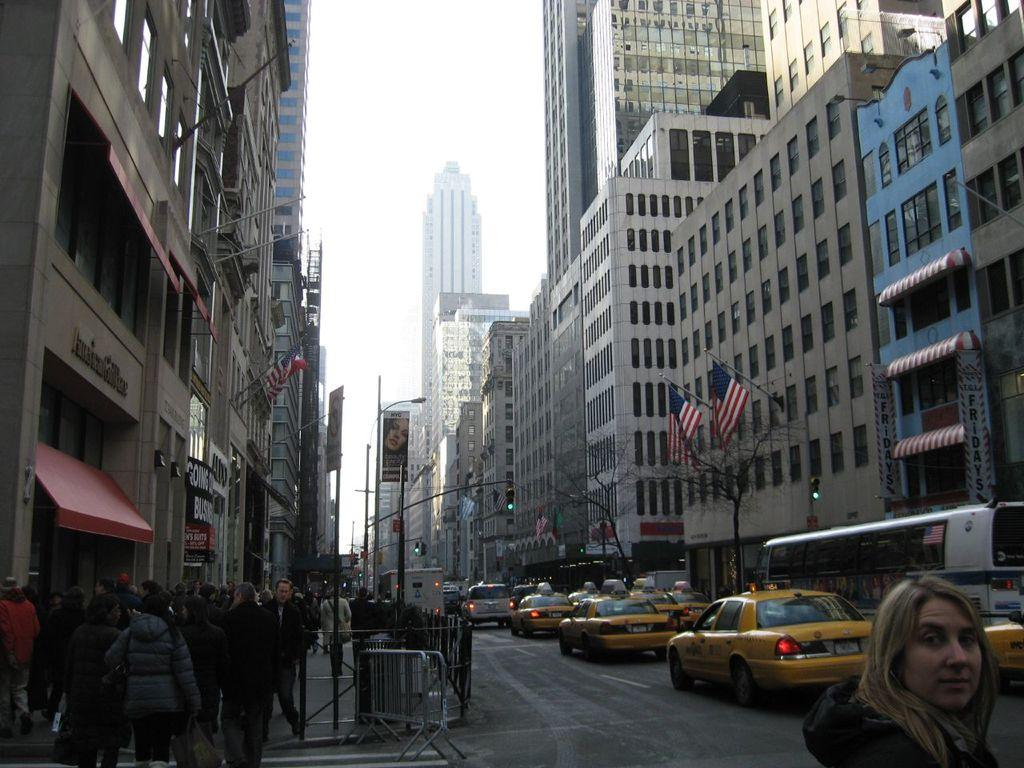<image>
Summarize the visual content of the image. People walking near a store that has a red front which says "SUITS". 